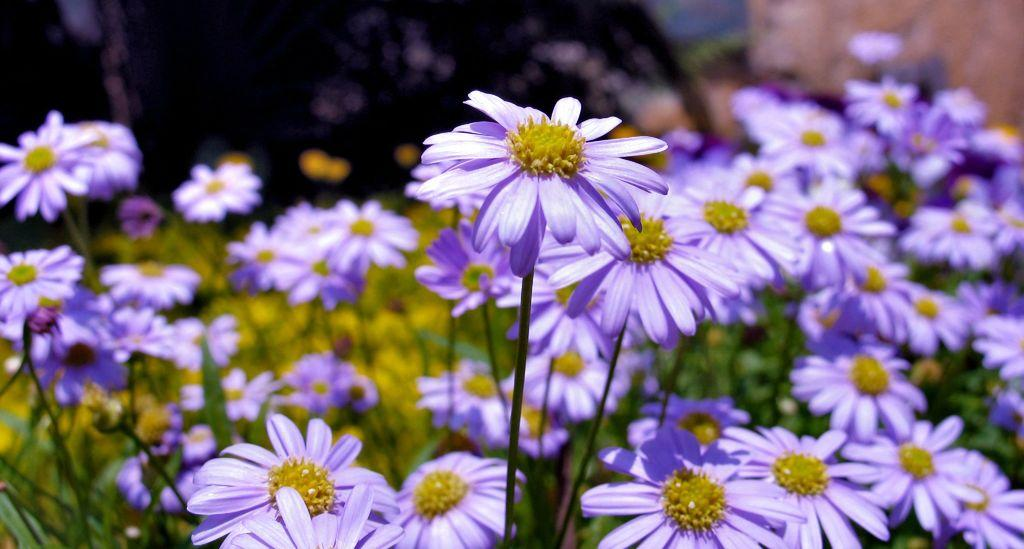What type of plants can be seen in the image? There are plants with flowers in the image. What color are the flowers on the plants? The flowers on the plants are lavender in color. What level of kitty can be seen in the image? There is no kitty present in the image, so it is not possible to determine the level of a kitty. 